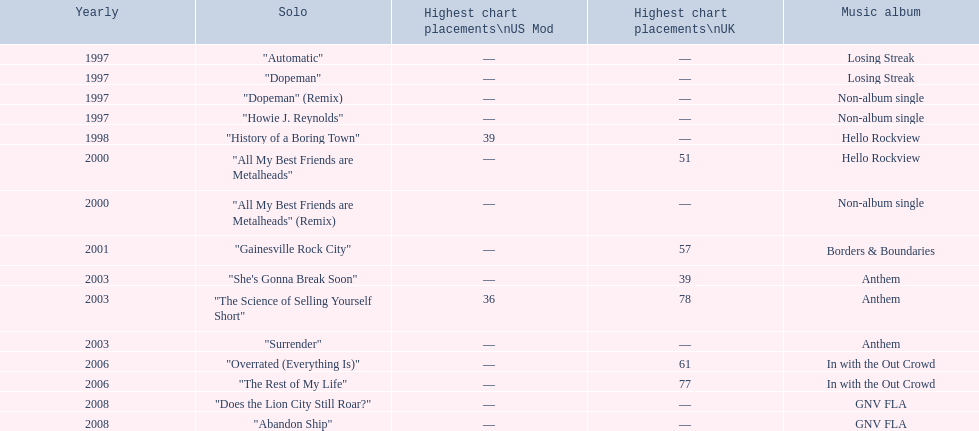How long was it between losing streak almbum and gnv fla in years. 11. 